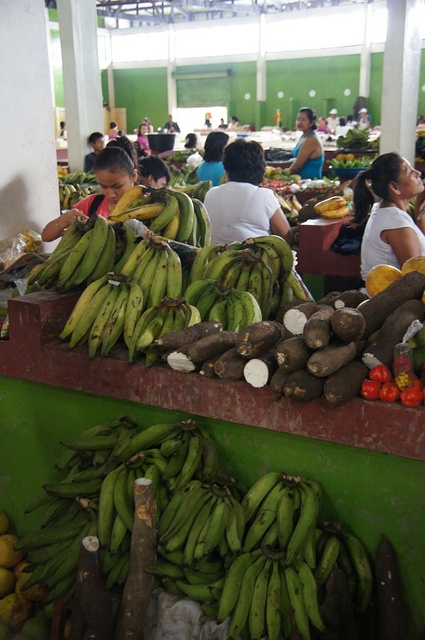Describe the objects in this image and their specific colors. I can see banana in darkgray, black, darkgreen, and gray tones, banana in darkgray, black, darkgreen, and gray tones, people in darkgray, black, maroon, and gray tones, people in darkgray, black, lightgray, and gray tones, and banana in darkgray, black, darkgreen, and olive tones in this image. 